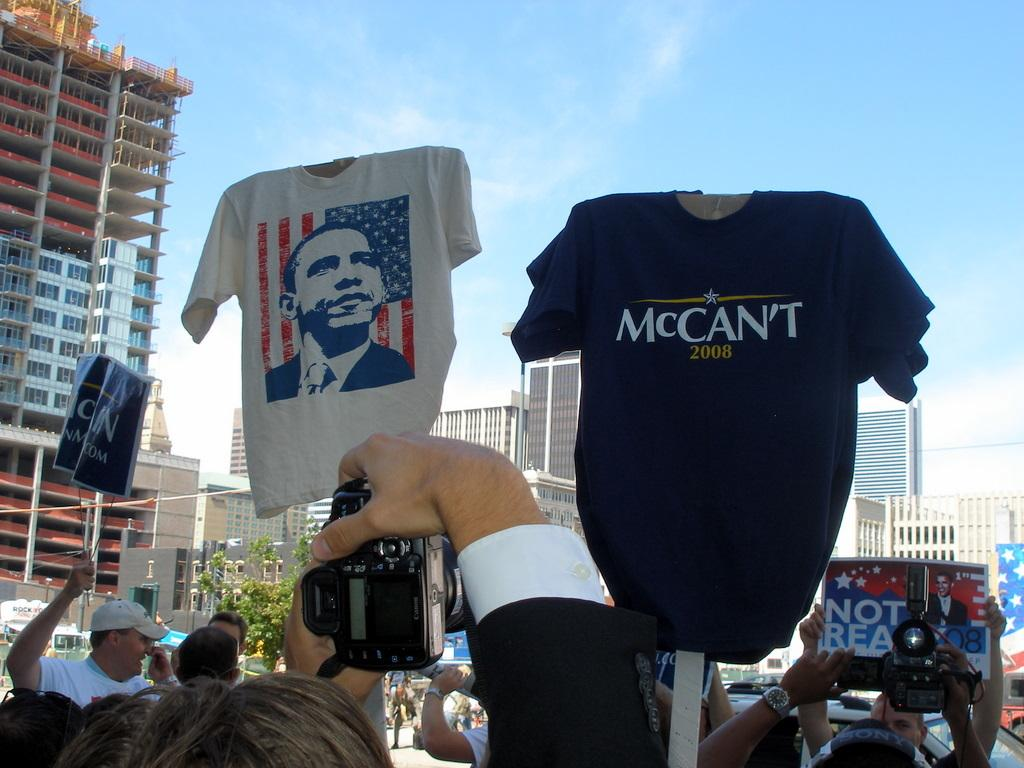Provide a one-sentence caption for the provided image. A blue Mccan't shirt with the year 2008 on it. 